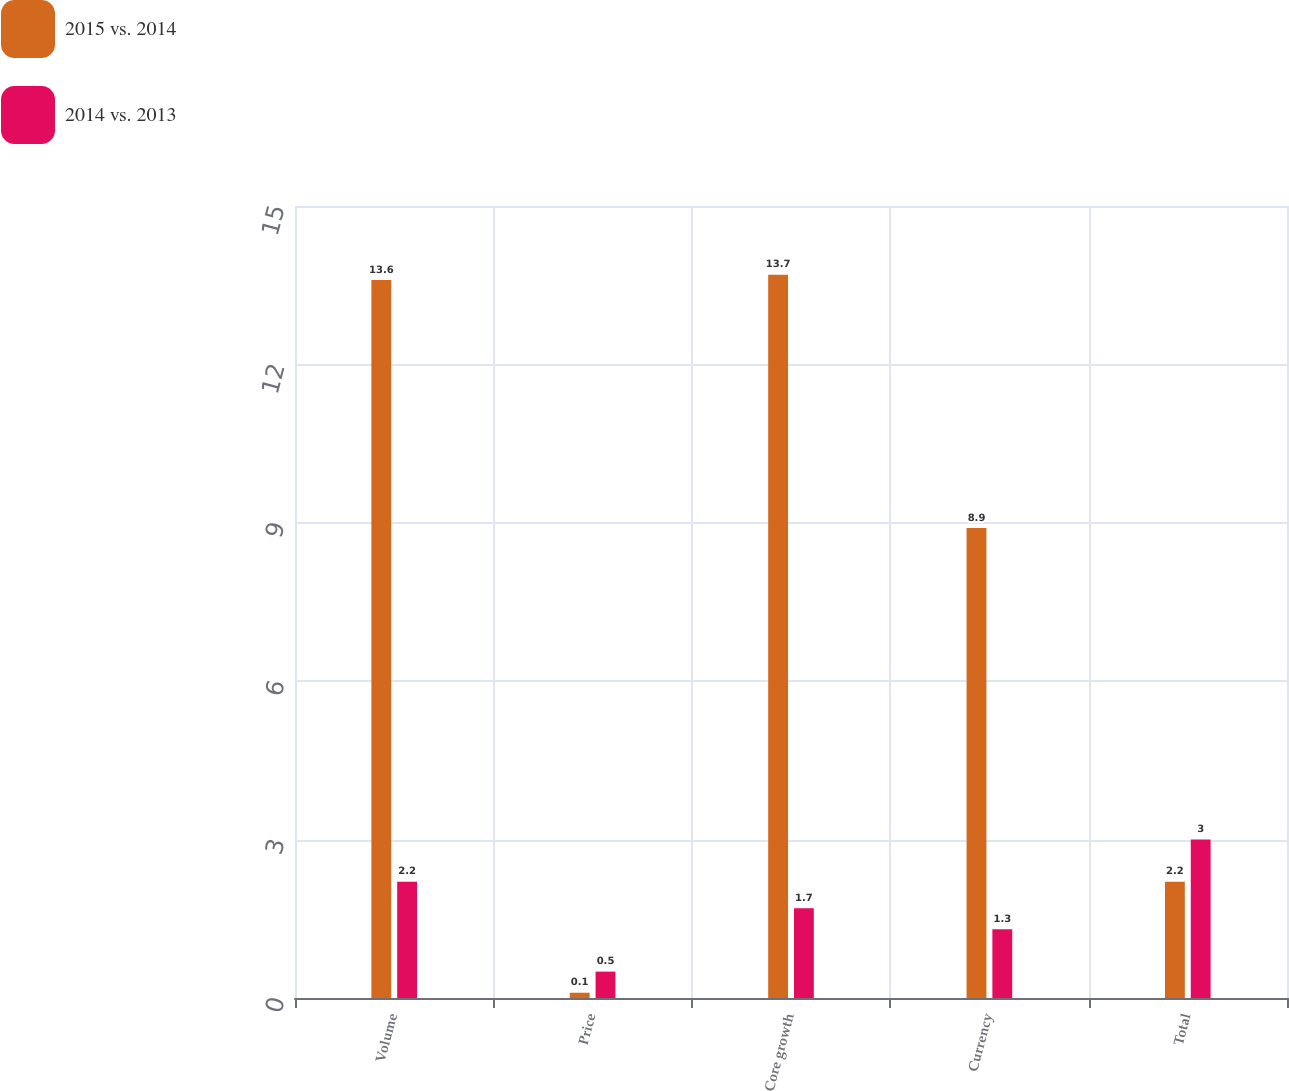<chart> <loc_0><loc_0><loc_500><loc_500><stacked_bar_chart><ecel><fcel>Volume<fcel>Price<fcel>Core growth<fcel>Currency<fcel>Total<nl><fcel>2015 vs. 2014<fcel>13.6<fcel>0.1<fcel>13.7<fcel>8.9<fcel>2.2<nl><fcel>2014 vs. 2013<fcel>2.2<fcel>0.5<fcel>1.7<fcel>1.3<fcel>3<nl></chart> 